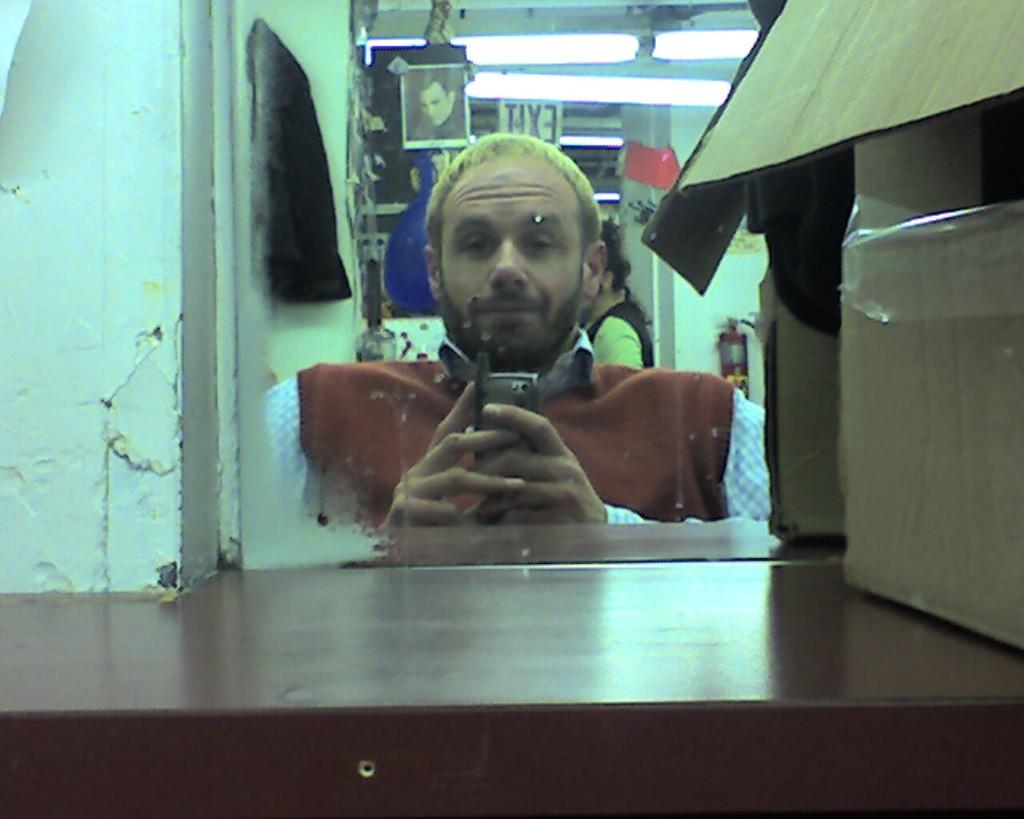What is the man in the image doing? The man is looking into a mirror. What object is the man holding in his hands? The man is holding a mobile in his hands. What is the man wearing in the image? The man is wearing a brown color sweater. What type of competition is the man participating in within the image? There is no indication of a competition in the image; the man is simply looking into a mirror and holding a mobile. Can you tell me how the man is flying in the image? The man is not flying in the image; he is standing and looking into a mirror. 